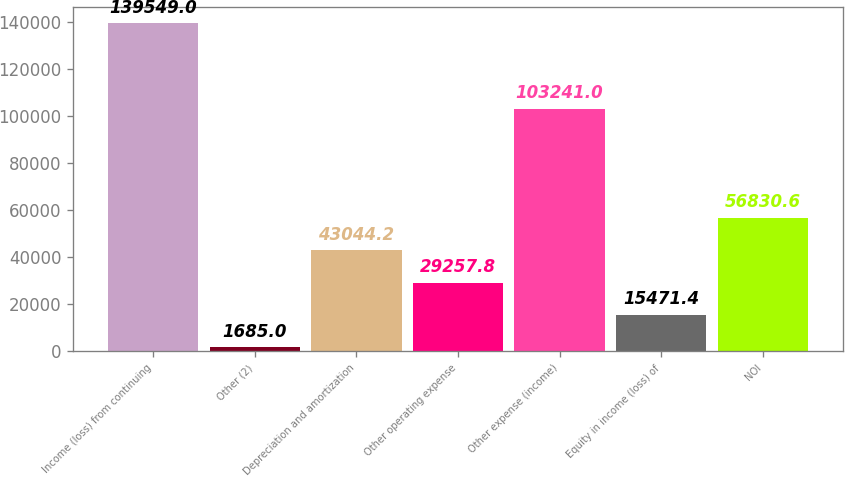Convert chart. <chart><loc_0><loc_0><loc_500><loc_500><bar_chart><fcel>Income (loss) from continuing<fcel>Other (2)<fcel>Depreciation and amortization<fcel>Other operating expense<fcel>Other expense (income)<fcel>Equity in income (loss) of<fcel>NOI<nl><fcel>139549<fcel>1685<fcel>43044.2<fcel>29257.8<fcel>103241<fcel>15471.4<fcel>56830.6<nl></chart> 